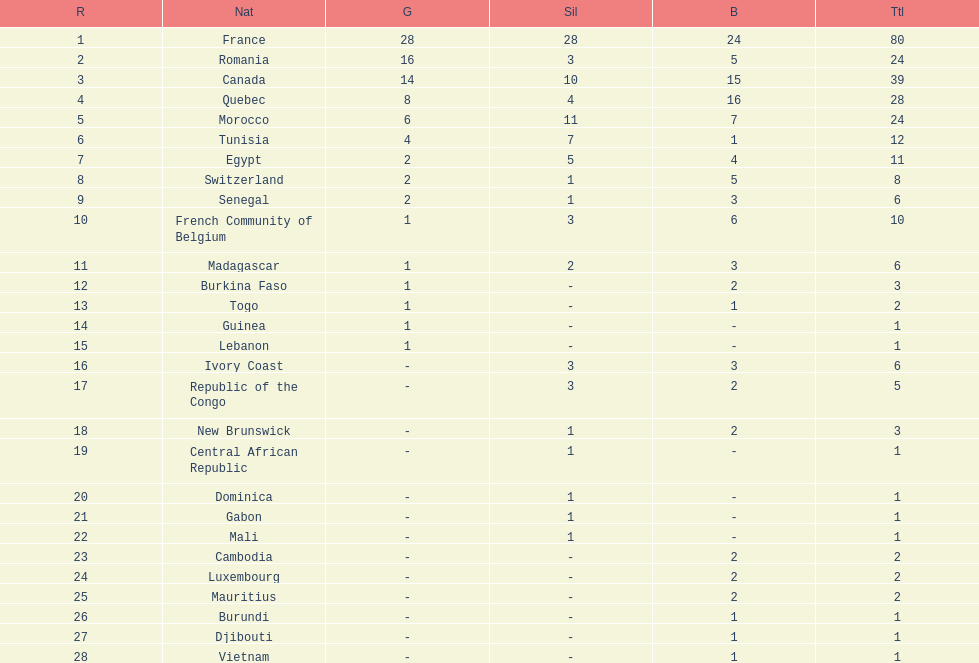How many counties have at least one silver medal? 18. 